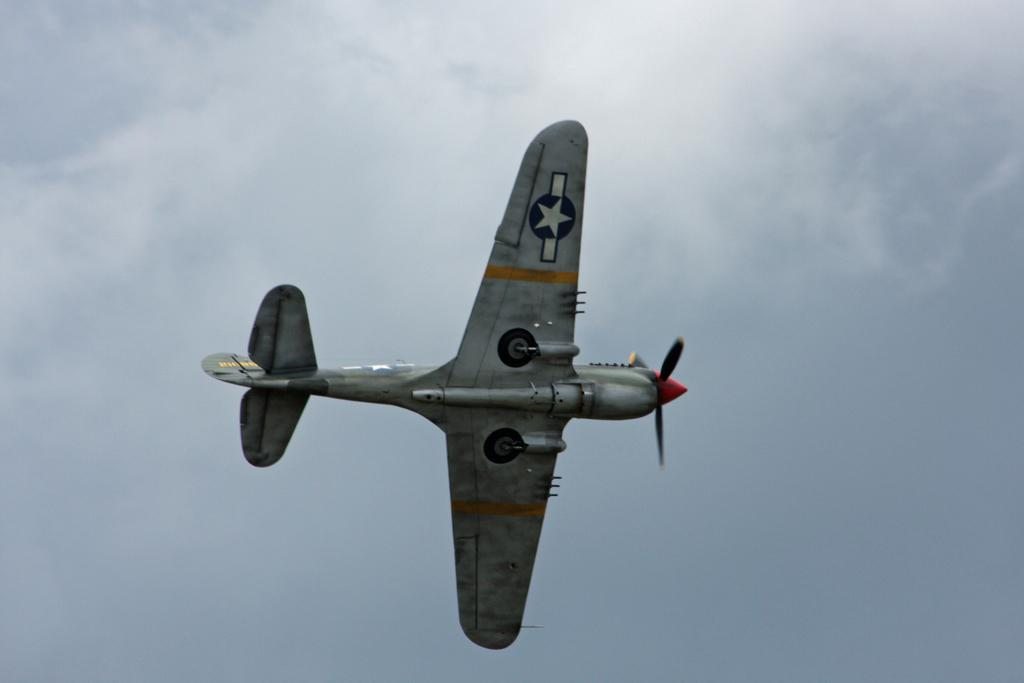What is the main subject of the image? The main subject of the image is an aircraft. What is the aircraft doing in the image? The aircraft is flying in the sky. How many clouds are visible on the shelf in the image? There is no shelf or clouds present in the image; it features an aircraft flying in the sky. 